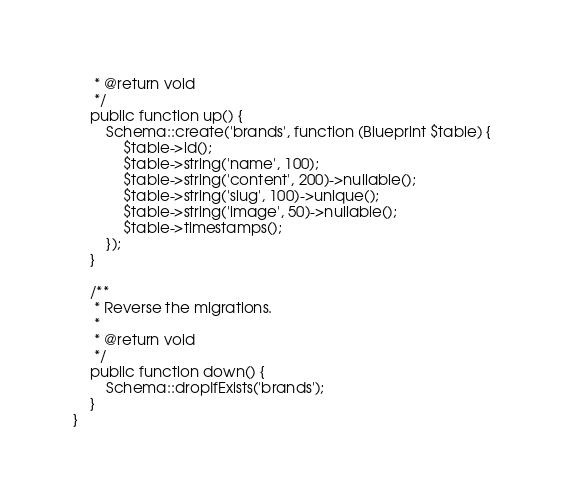<code> <loc_0><loc_0><loc_500><loc_500><_PHP_>     * @return void
     */
    public function up() {
        Schema::create('brands', function (Blueprint $table) {
            $table->id();
            $table->string('name', 100);
            $table->string('content', 200)->nullable();
            $table->string('slug', 100)->unique();
            $table->string('image', 50)->nullable();
            $table->timestamps();
        });
    }

    /**
     * Reverse the migrations.
     *
     * @return void
     */
    public function down() {
        Schema::dropIfExists('brands');
    }
}
</code> 